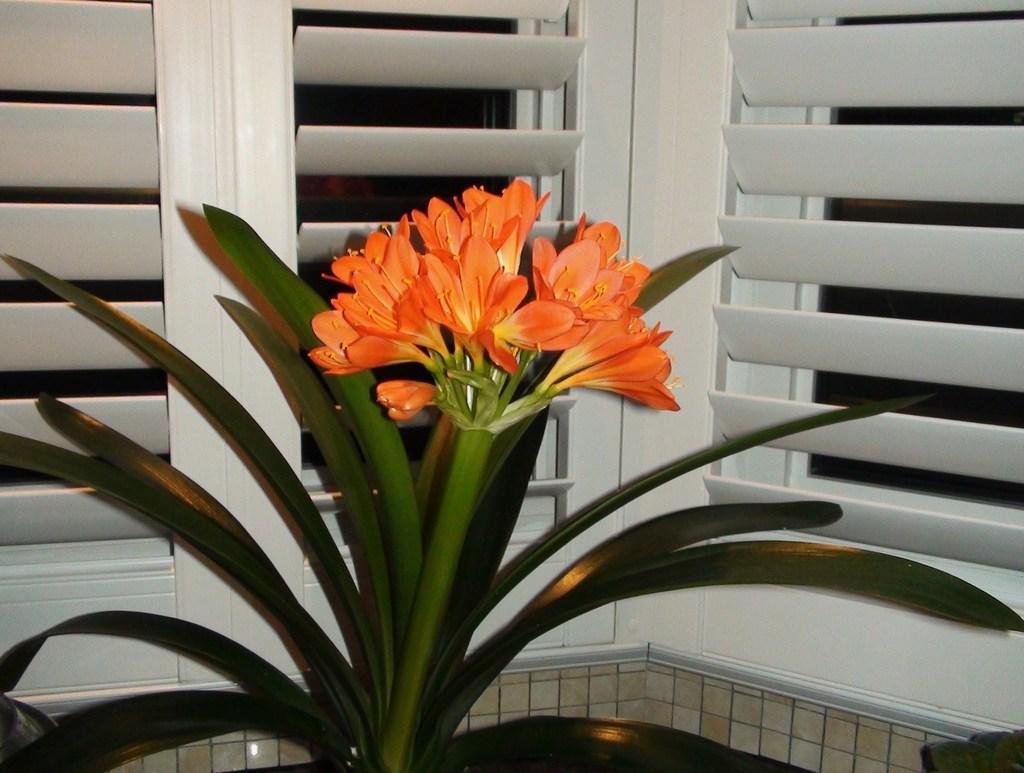How would you summarize this image in a sentence or two? In this image, we can see a green plant, we can see some flowers, we can see some white color windows. 